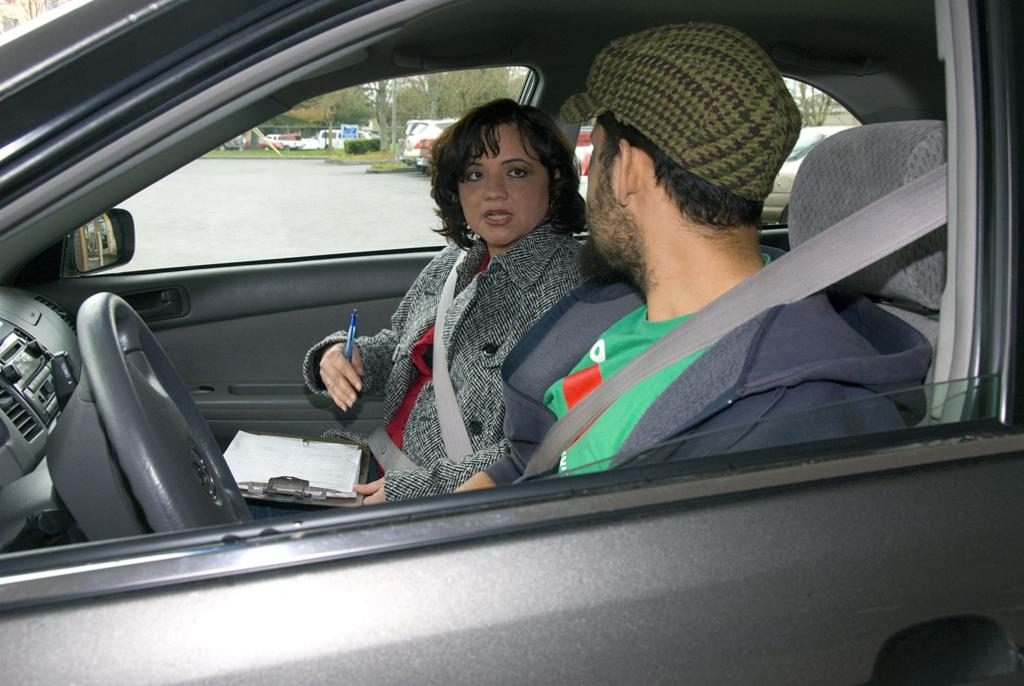How many people are in the image? There are two persons in the image. What are the persons doing in the image? The persons are sitting in a car. What is the woman holding in the image? The woman is holding a pad and a pen. What can be seen in the background of the image? There is a path visible in the background, and there are multiple cars in the background. How many army tanks are visible in the image? There are no army tanks present in the image. What is the amount of money the persons are discussing in the image? There is no indication of a discussion about money in the image. 